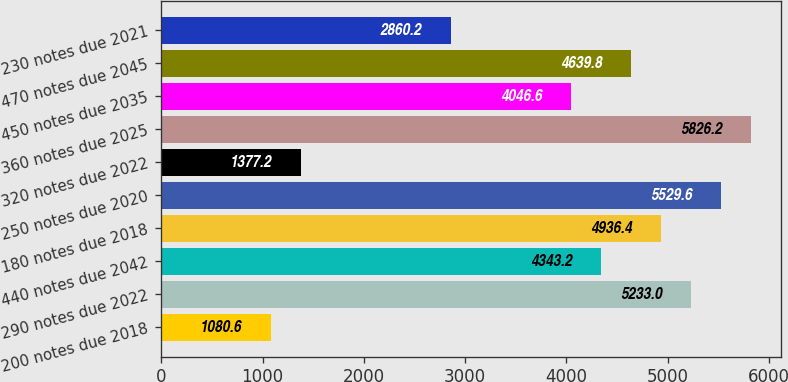Convert chart. <chart><loc_0><loc_0><loc_500><loc_500><bar_chart><fcel>200 notes due 2018<fcel>290 notes due 2022<fcel>440 notes due 2042<fcel>180 notes due 2018<fcel>250 notes due 2020<fcel>320 notes due 2022<fcel>360 notes due 2025<fcel>450 notes due 2035<fcel>470 notes due 2045<fcel>230 notes due 2021<nl><fcel>1080.6<fcel>5233<fcel>4343.2<fcel>4936.4<fcel>5529.6<fcel>1377.2<fcel>5826.2<fcel>4046.6<fcel>4639.8<fcel>2860.2<nl></chart> 